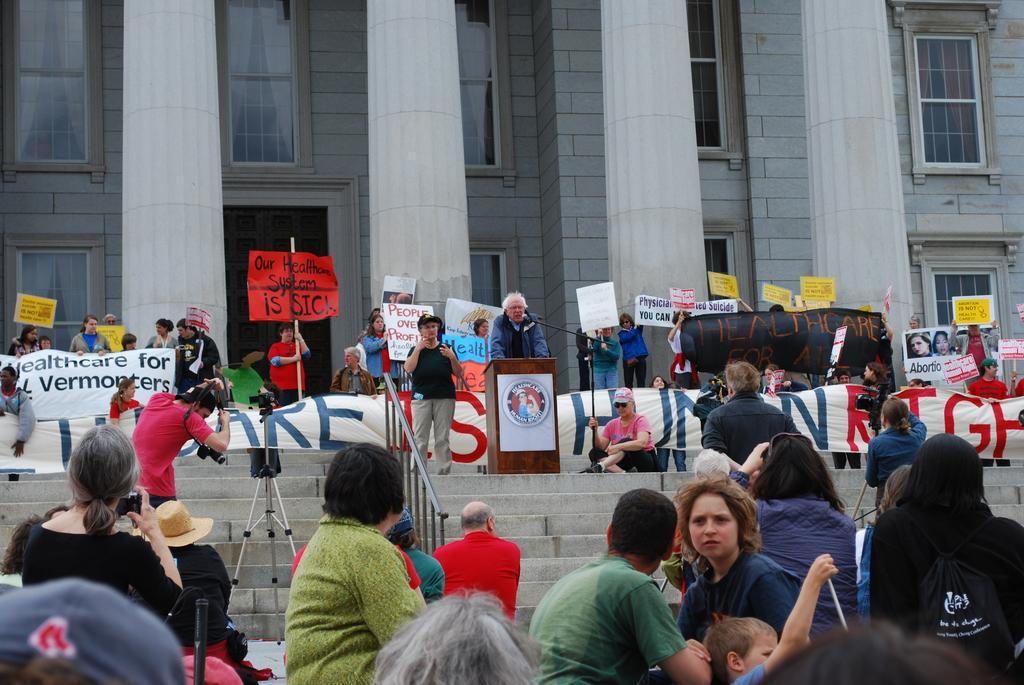How many people are in the image? There are many people in the image. What are the people doing in the image? The people are standing and sitting on steps in front of a building. What is the building like in the image? The building has many windows. What are the people holding in the image? The people are holding banners. What are the people's hobbies, as depicted in the image? The image does not provide information about the people's hobbies; it only shows them standing and sitting on steps while holding banners. 